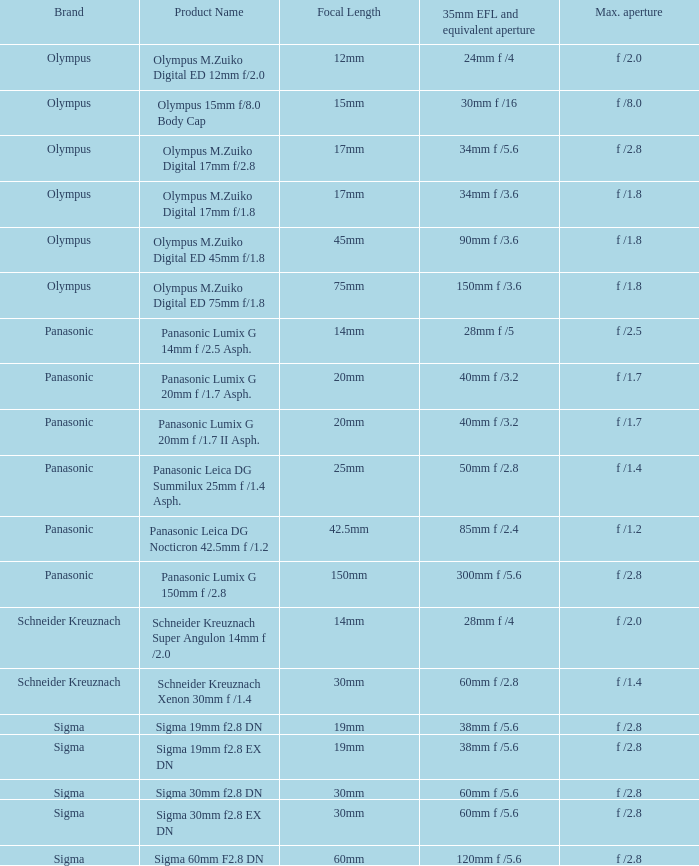What is the largest aperture size for a lens with a 20mm focal length? F /1.7, f /1.7. 